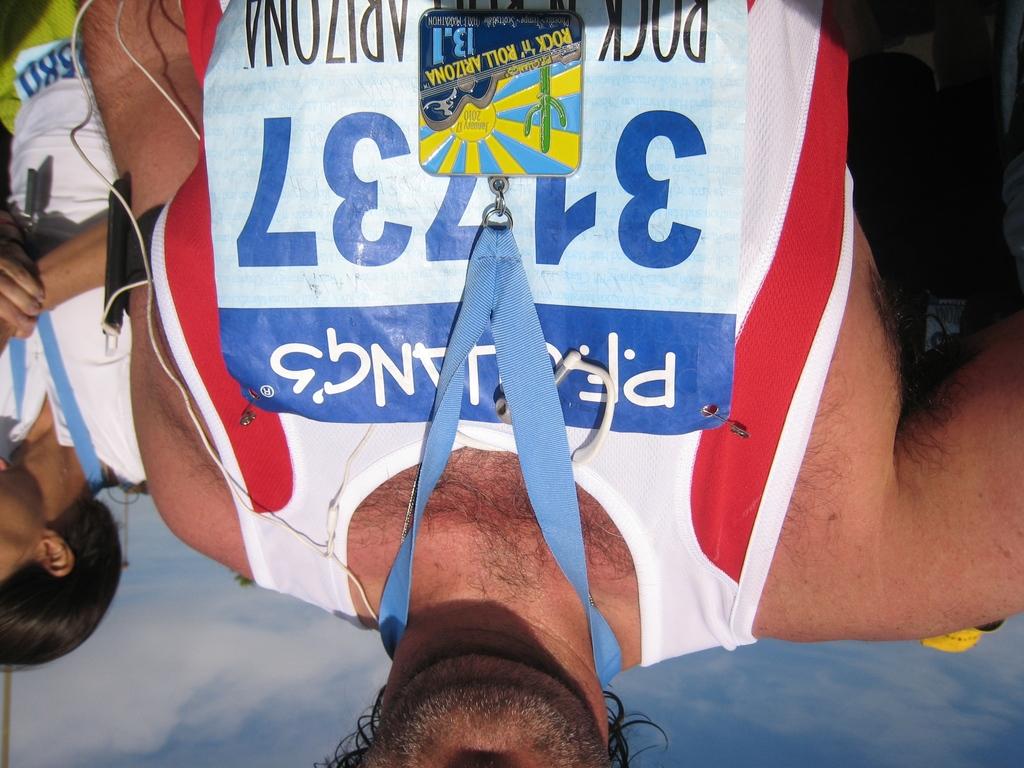What is on his lanyard?
Keep it short and to the point. Rock n roll arizona. Which company  is sponsoring this event?
Offer a terse response. P.f. chang's. 